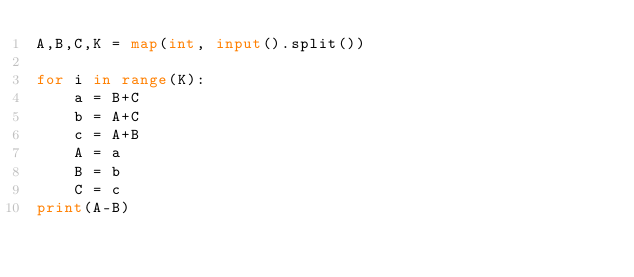Convert code to text. <code><loc_0><loc_0><loc_500><loc_500><_Python_>A,B,C,K = map(int, input().split())

for i in range(K):
    a = B+C
    b = A+C
    c = A+B
    A = a
    B = b
    C = c
print(A-B)</code> 